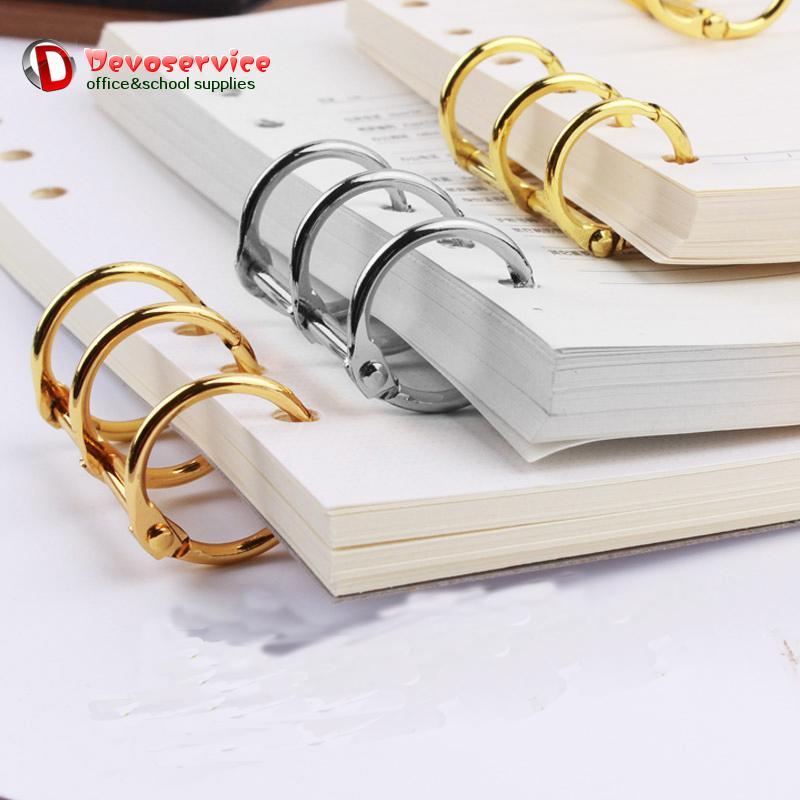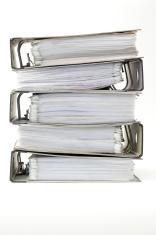The first image is the image on the left, the second image is the image on the right. Examine the images to the left and right. Is the description "There is two stacks of binders in the center of the images." accurate? Answer yes or no. No. 